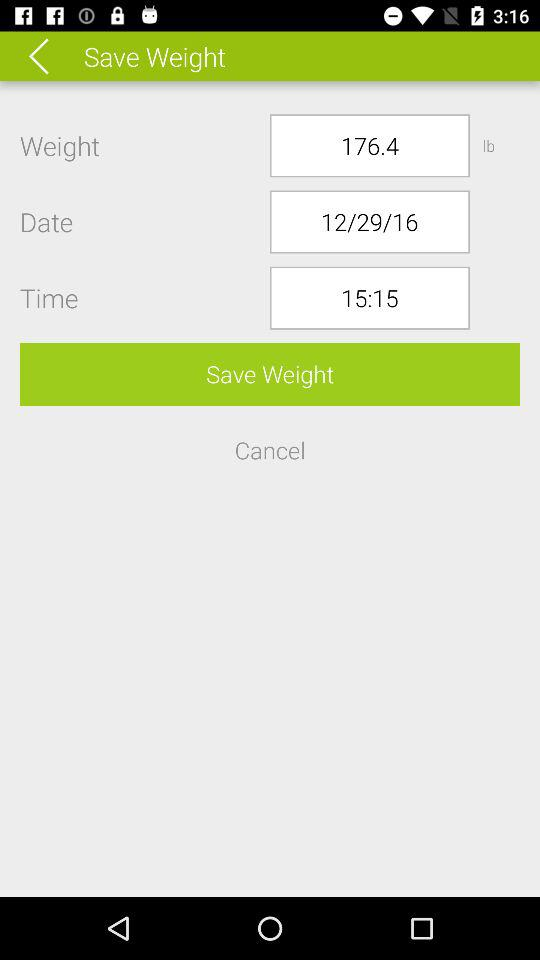What is the time? The time is 15:15. 